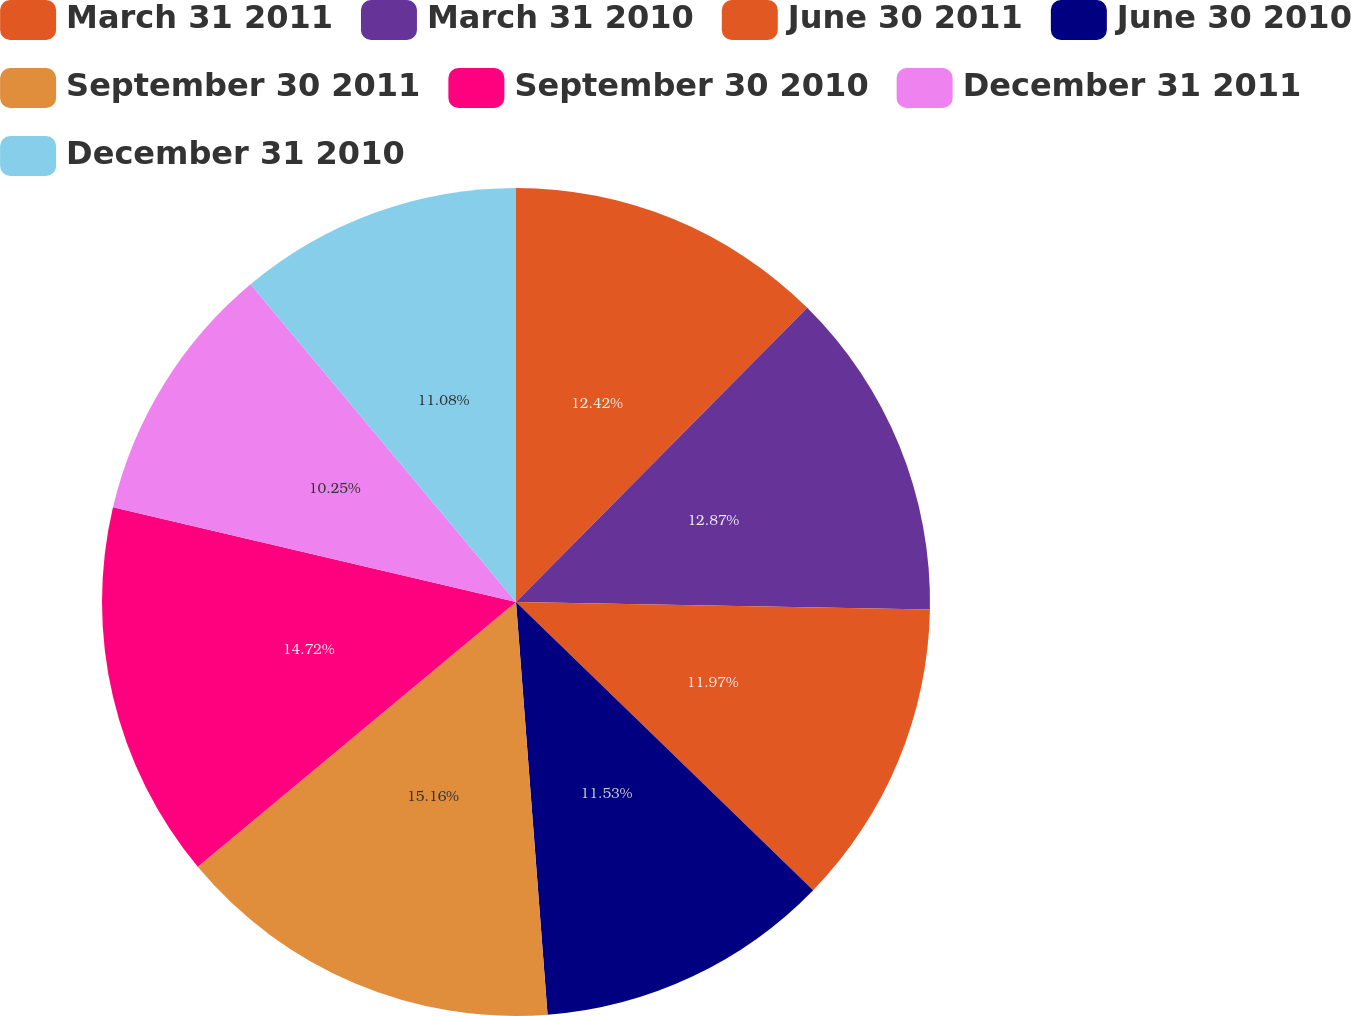Convert chart to OTSL. <chart><loc_0><loc_0><loc_500><loc_500><pie_chart><fcel>March 31 2011<fcel>March 31 2010<fcel>June 30 2011<fcel>June 30 2010<fcel>September 30 2011<fcel>September 30 2010<fcel>December 31 2011<fcel>December 31 2010<nl><fcel>12.42%<fcel>12.87%<fcel>11.97%<fcel>11.53%<fcel>15.17%<fcel>14.72%<fcel>10.25%<fcel>11.08%<nl></chart> 